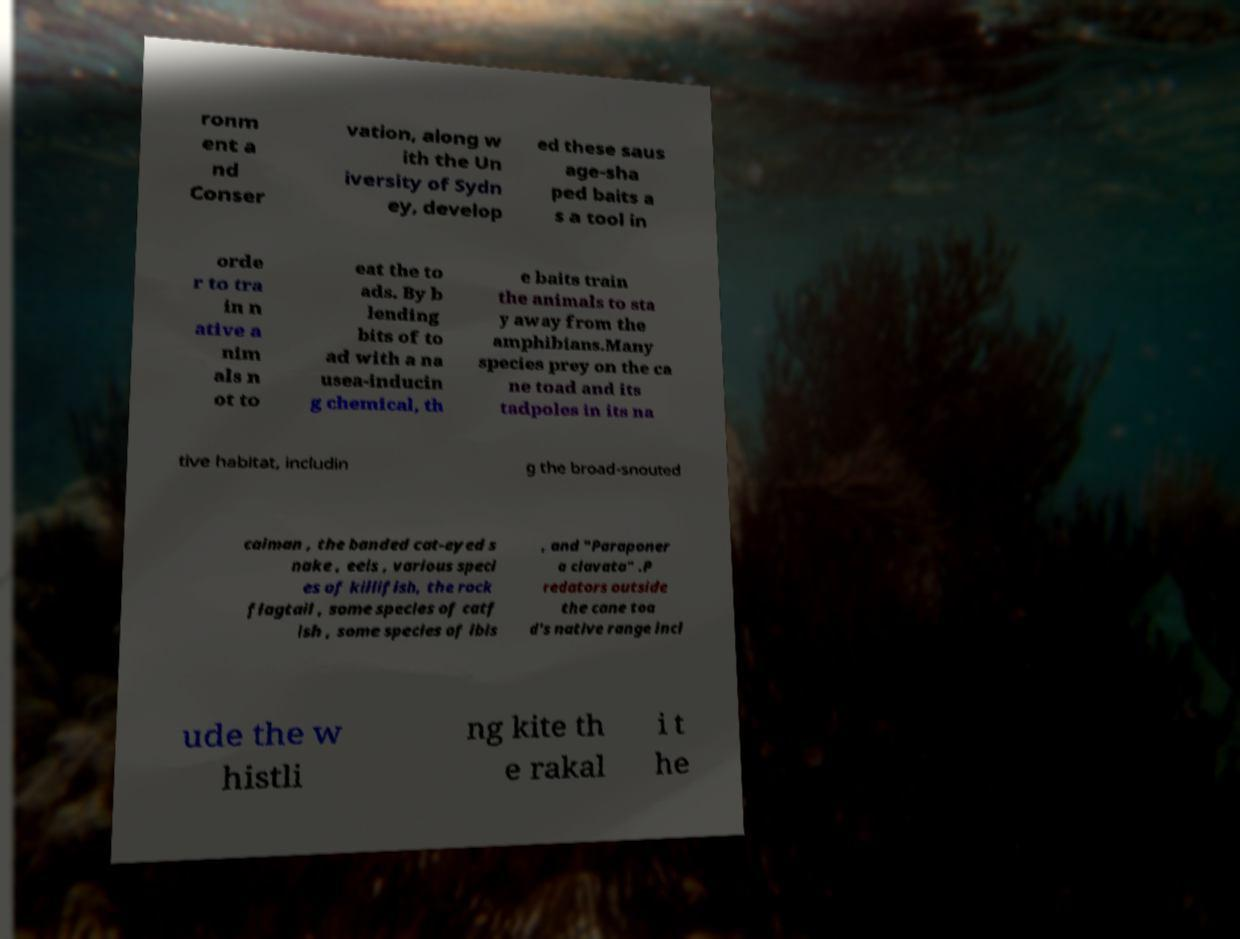Could you assist in decoding the text presented in this image and type it out clearly? ronm ent a nd Conser vation, along w ith the Un iversity of Sydn ey, develop ed these saus age-sha ped baits a s a tool in orde r to tra in n ative a nim als n ot to eat the to ads. By b lending bits of to ad with a na usea-inducin g chemical, th e baits train the animals to sta y away from the amphibians.Many species prey on the ca ne toad and its tadpoles in its na tive habitat, includin g the broad-snouted caiman , the banded cat-eyed s nake , eels , various speci es of killifish, the rock flagtail , some species of catf ish , some species of ibis , and "Paraponer a clavata" .P redators outside the cane toa d's native range incl ude the w histli ng kite th e rakal i t he 